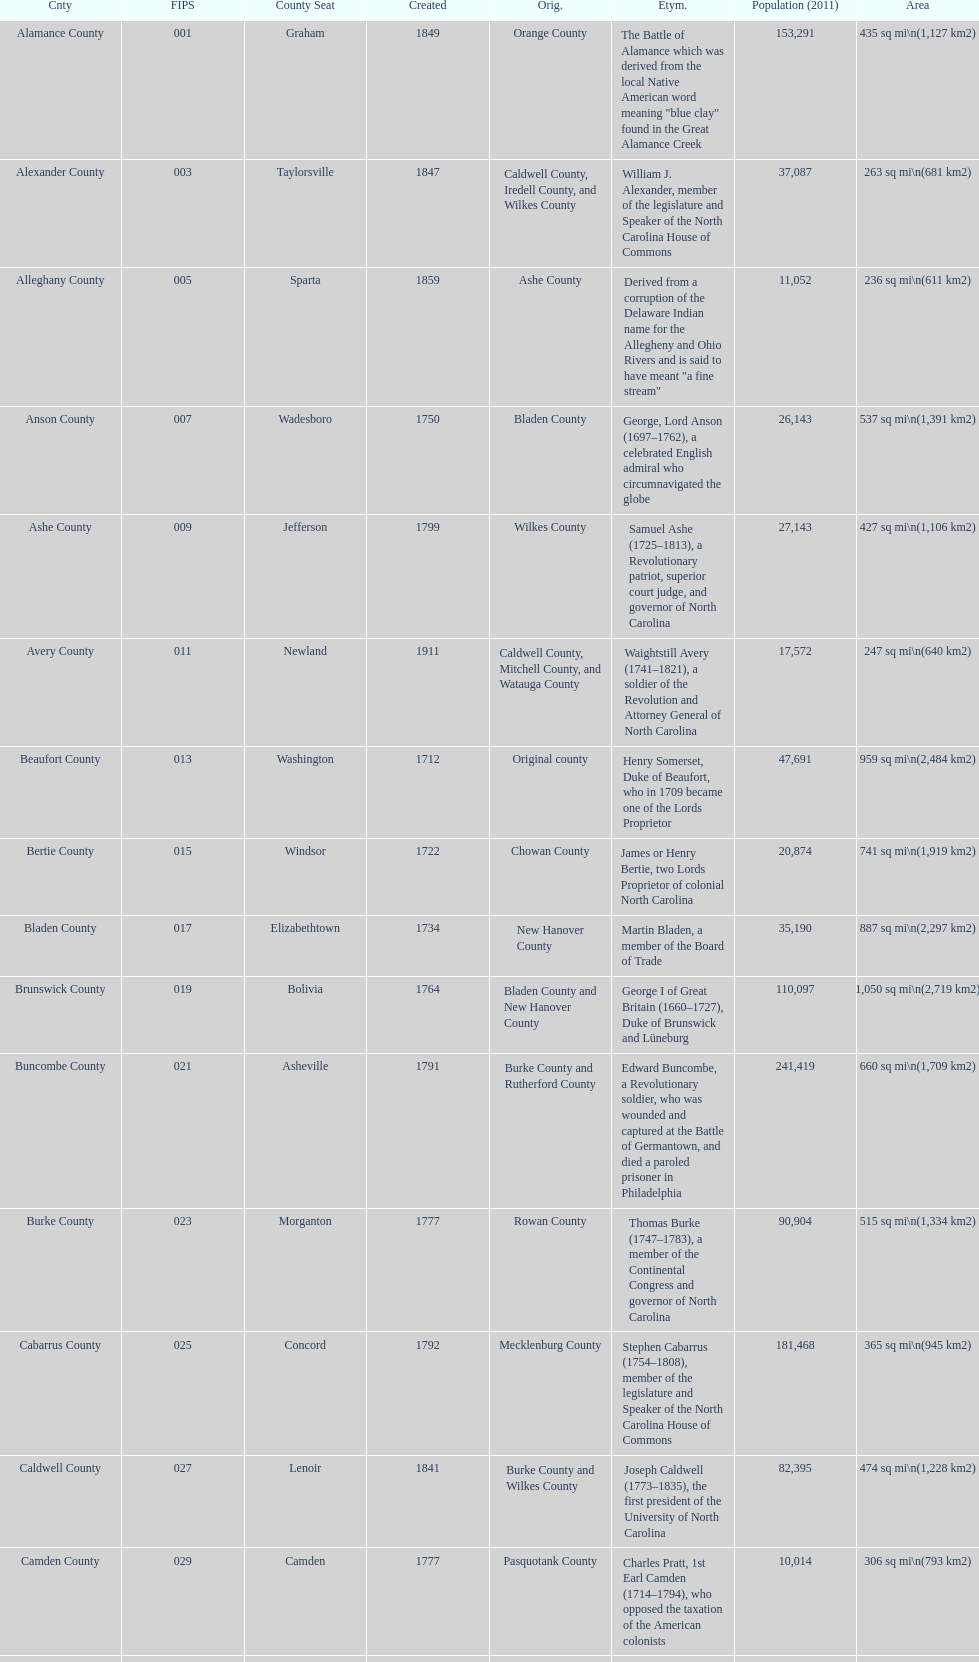What number of counties are named for us presidents? 3. 